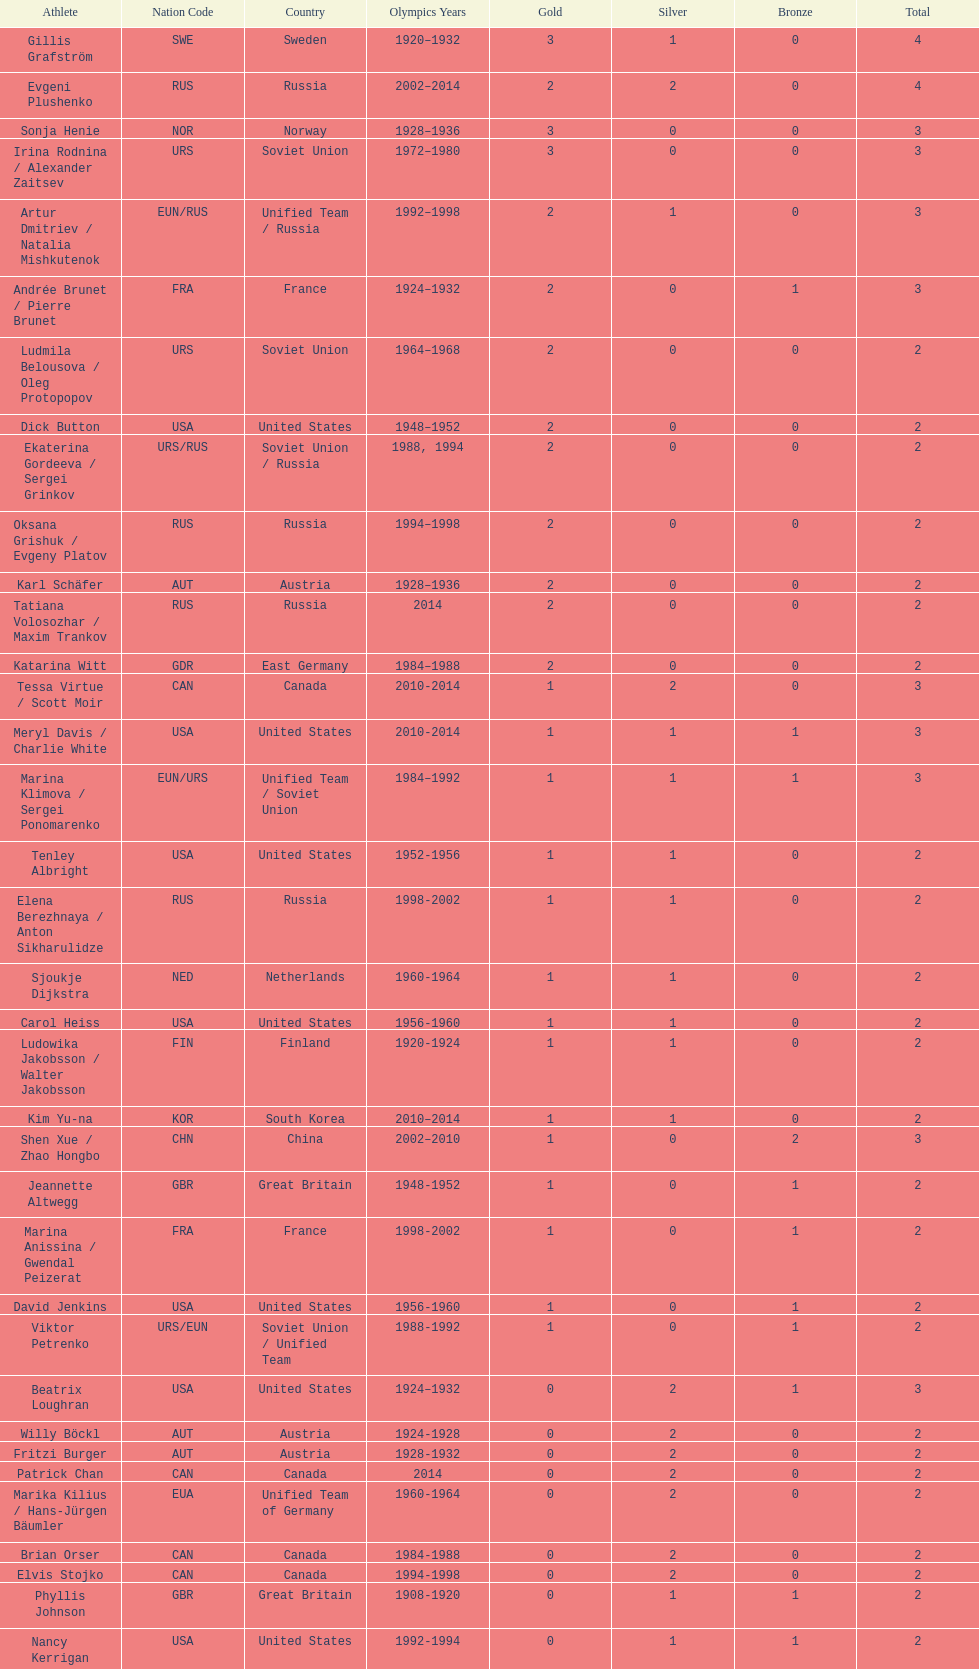Which athlete was from south korea after the year 2010? Kim Yu-na. 